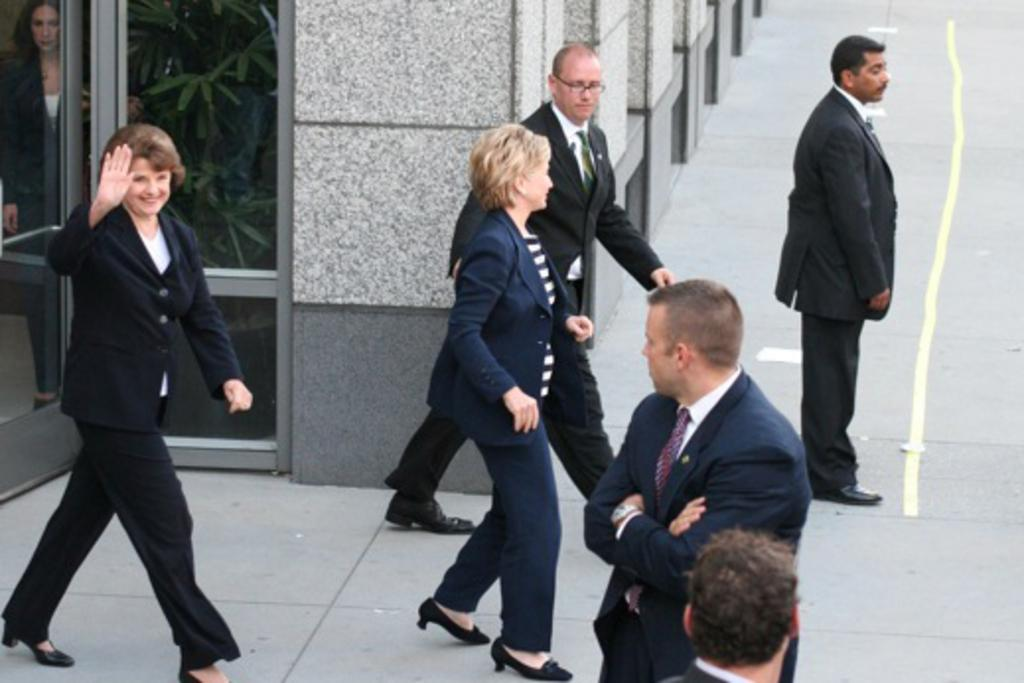How many people are in the image? There is a group of people in the image, but the exact number is not specified. Where are the people located in the image? The group of people is at the bottom of the image. What can be seen in the background of the image? There is a wall and a glass door in the background of the image. What type of art is displayed on the wall in the image? There is no art displayed on the wall in the image; only a wall and a glass door are visible in the background. 